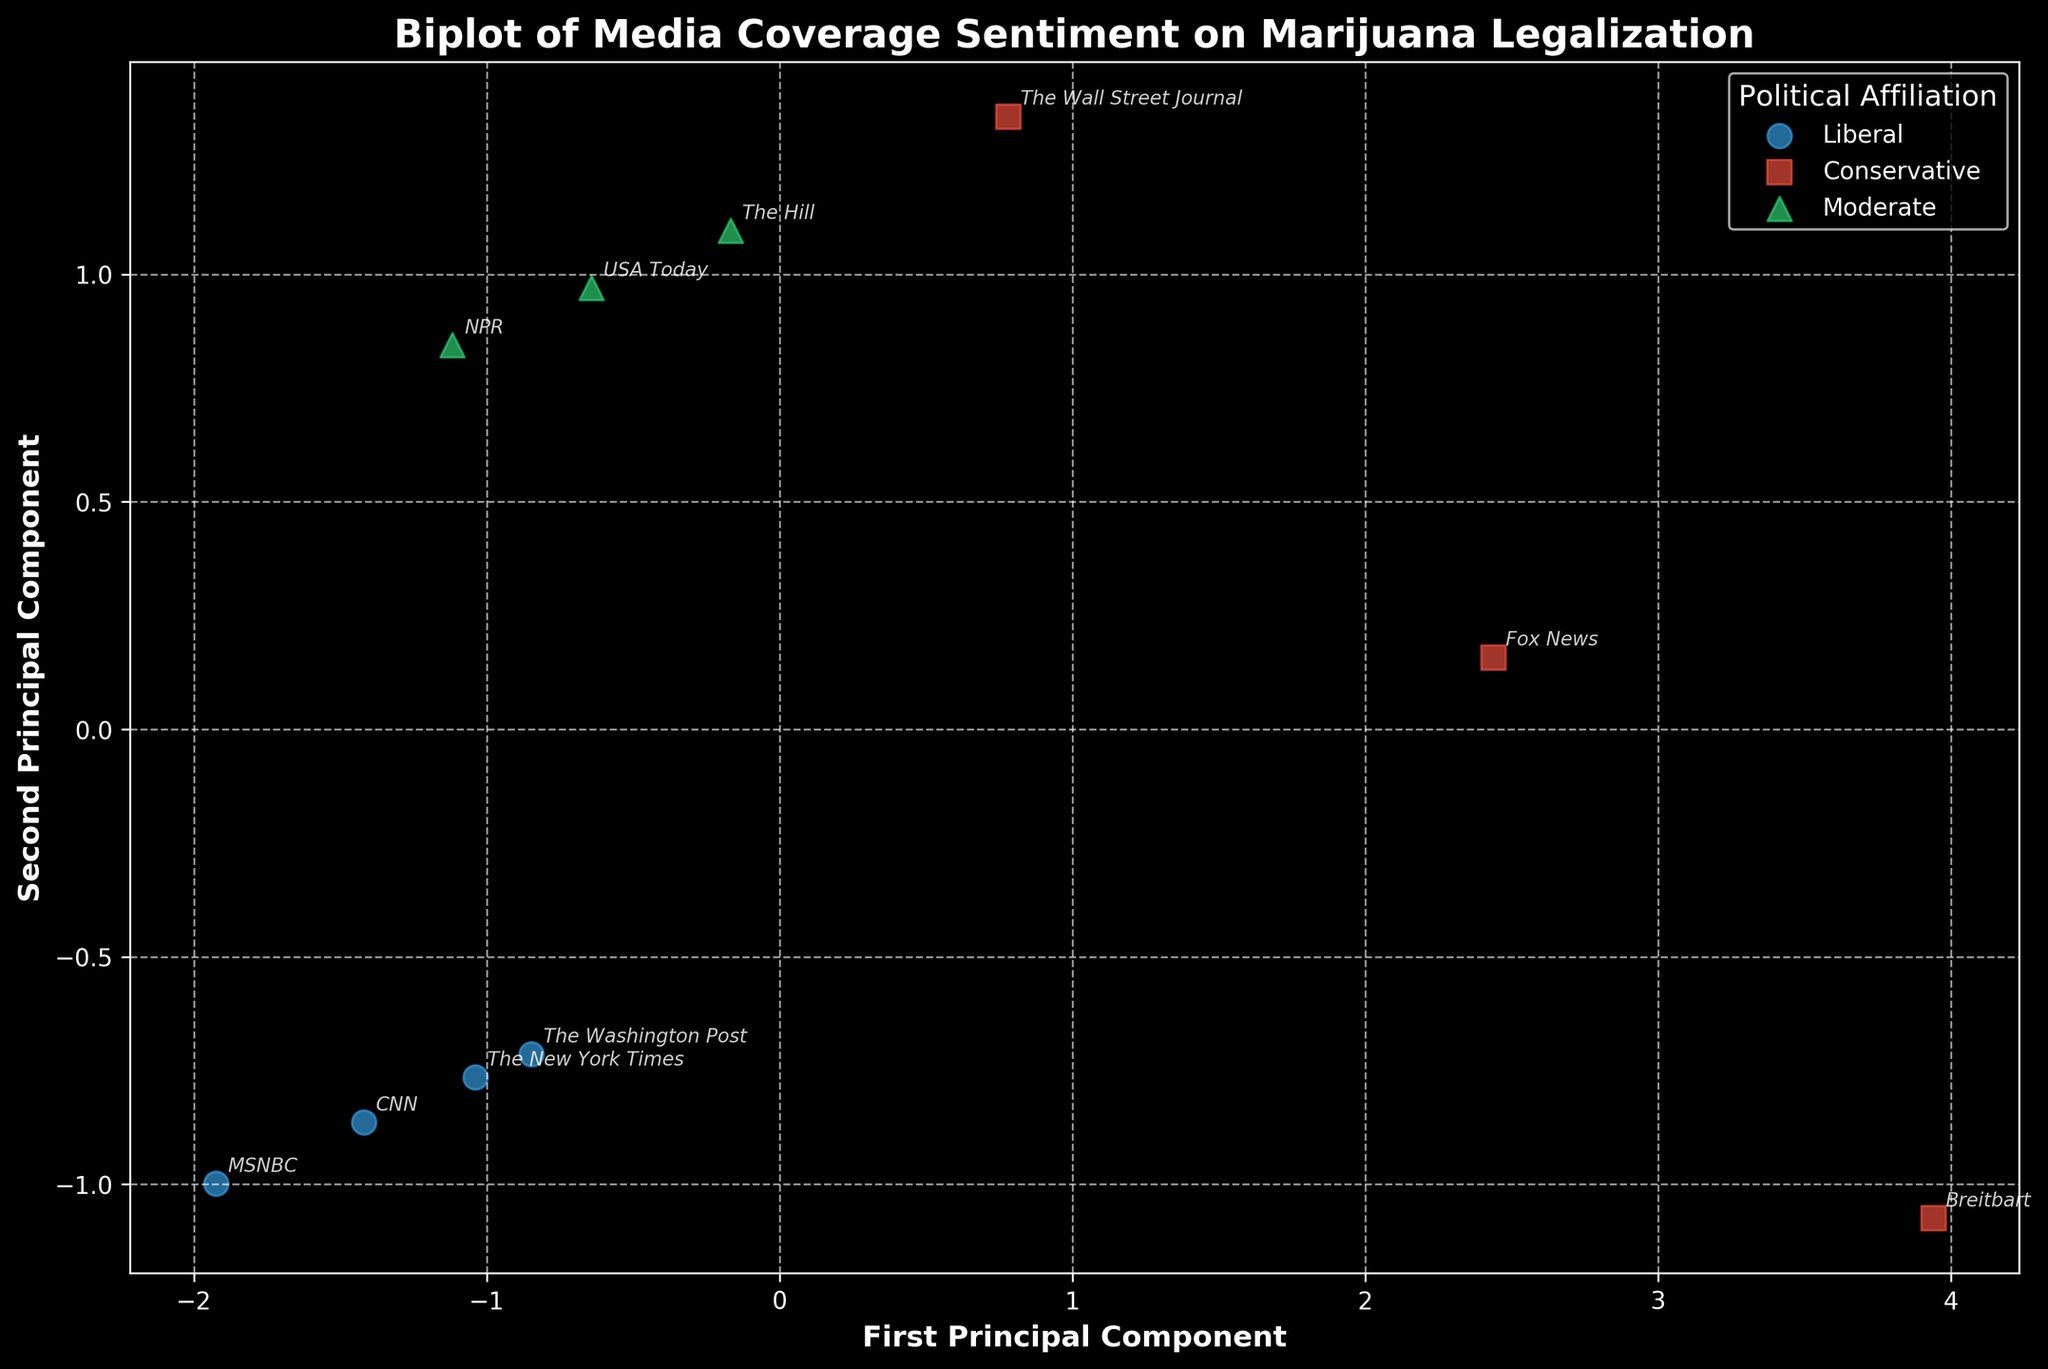What does the title of the figure state? The title is usually written at the top of the figure. In this plot, you can see the title clearly mentioning the context of analysis. The title reads "Biplot of Media Coverage Sentiment on Marijuana Legalization".
Answer: Biplot of Media Coverage Sentiment on Marijuana Legalization How many political affiliation groups are represented in the plot? The legend located on the side of the plot usually indicates the distinct groups being compared. In this case, the legend lists three political affiliations: Liberal, Conservative, and Moderate.
Answer: Three Which political affiliation has the highest concentration of positive sentiment? To determine this, you should look at the plotting area for the colors and markers associated with positive sentiment. According to the plot, the Liberal media outlets are predominantly located in the area suggesting a higher positive sentiment.
Answer: Liberal Is "Breitbart" closer to the 'Negative' vector or the 'Positive' vector? To answer this, identify the position of "Breitbart" in the scatter plot and its proximity to the arrows indicating the negative and positive sentiment vectors. "Breitbart" is closer to the 'Negative' vector.
Answer: Negative Which media outlet is closest to the 'Legalization' vector direction, indicating strong legalization support? Check the proximity of each media outlet to the 'Legalization' arrow vector. "MSNBC" and "CNN" are placed closer to the 'Legalization' direction, suggesting higher support for marijuana legalization. Among these, "MSNBC" appears the closest.
Answer: MSNBC Which media outlets fall under the 'Moderate' political affiliation? To identify these, look at the areas marked with the color and marker specified for Moderate in the legend, and then locate the corresponding media outlets listed in the plot. The media outlets classified as Moderate are "NPR", "USA Today", and "The Hill".
Answer: NPR, USA Today, The Hill Are there any Liberal media outlets positioned closer to the 'Negative' vector? Examine the placements of Liberal media outlets in relation to the direction of the 'Negative' vector. None of the Liberal media outlets like "CNN", "MSNBC", "The New York Times", and "The Washington Post" are closely positioned to the 'Negative' vector.
Answer: No Which political group shows the greatest variance in sentiment (both positive and negative)? This requires observing the spread of the political groups in terms of their positions relative to the positive and negative vectors. Conservative media outlets like "Fox News" and "Breitbart" exhibit the greatest spread, indicating a higher variance in sentiment.
Answer: Conservative Which media outlet among the Conservatives has a higher legalization support? Compare the positioning of Conservative media outlets "Fox News", "Breitbart", and "The Wall Street Journal" in relation to the 'Legalization' vector. "The Wall Street Journal" is positioned closer to the 'Legalization' vector compared to others.
Answer: The Wall Street Journal Does the 'Neutral Coverage' vector significantly influence the clustering of any particular media outlet? Look at the positioning of media outlets along the 'Neutral Coverage' vector and whether any group of points shows a noticeable clustering. In this plot, none of the media outlets are significantly clustered around the 'Neutral Coverage' vector.
Answer: No 